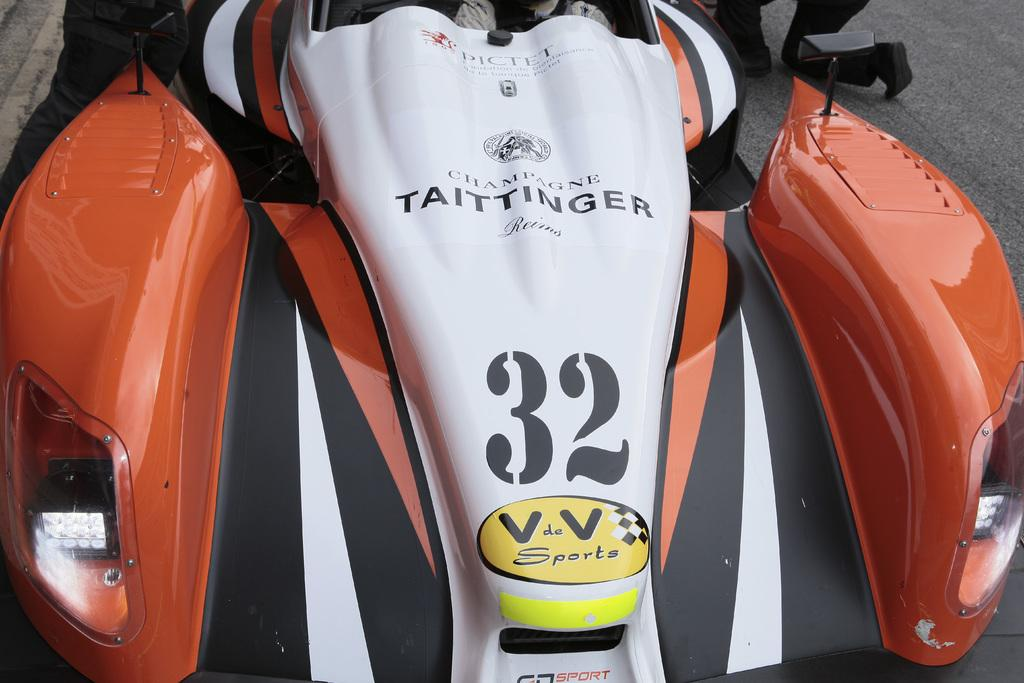What is the main subject of the image? The main subject of the image is a vehicle on the road. Are there any people present in the image? Yes, there are two persons on the road in the image. What type of glove is the zebra wearing in the image? There is no glove or zebra present in the image. 